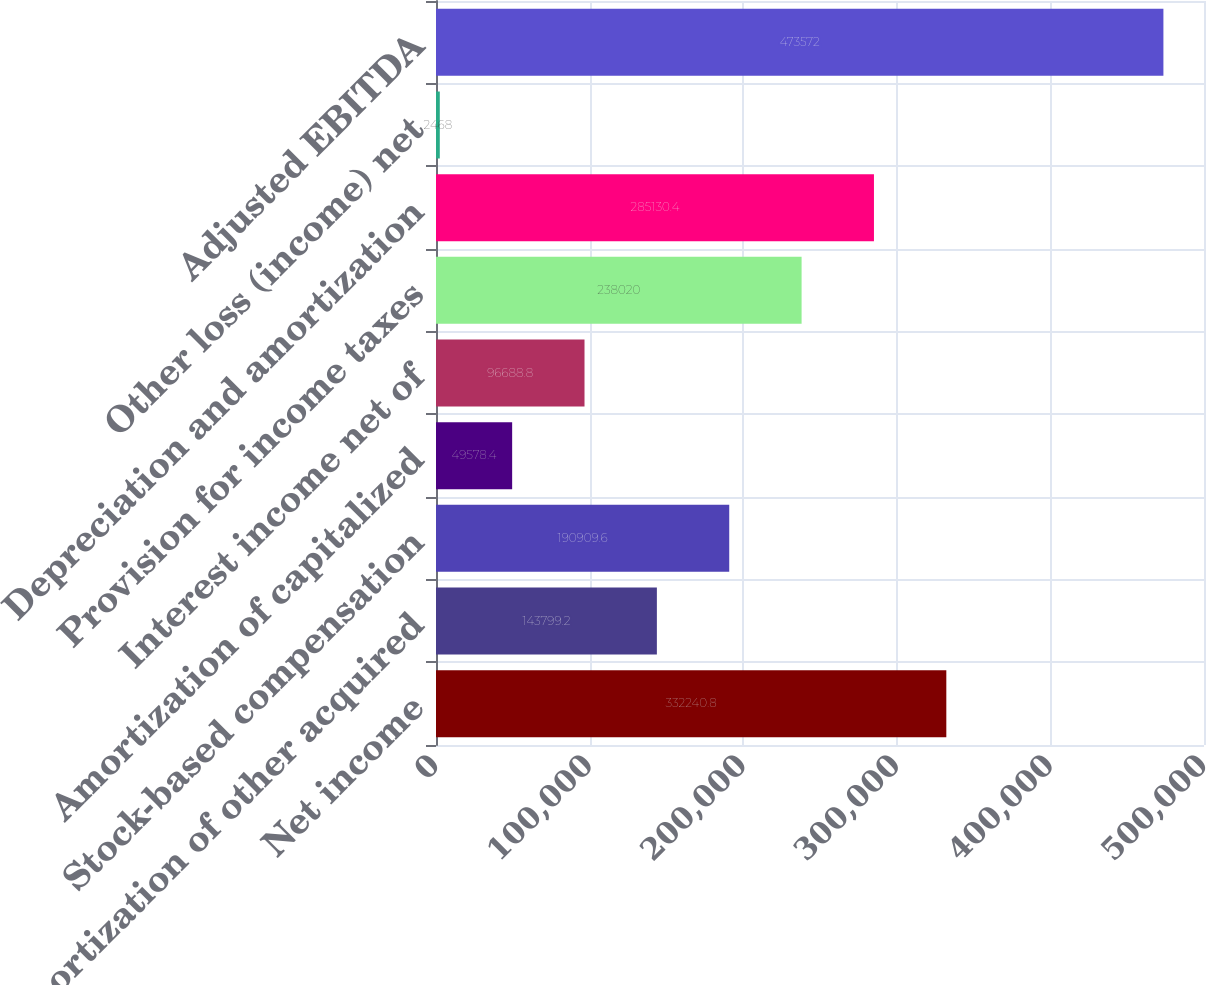<chart> <loc_0><loc_0><loc_500><loc_500><bar_chart><fcel>Net income<fcel>Amortization of other acquired<fcel>Stock-based compensation<fcel>Amortization of capitalized<fcel>Interest income net of<fcel>Provision for income taxes<fcel>Depreciation and amortization<fcel>Other loss (income) net<fcel>Adjusted EBITDA<nl><fcel>332241<fcel>143799<fcel>190910<fcel>49578.4<fcel>96688.8<fcel>238020<fcel>285130<fcel>2468<fcel>473572<nl></chart> 